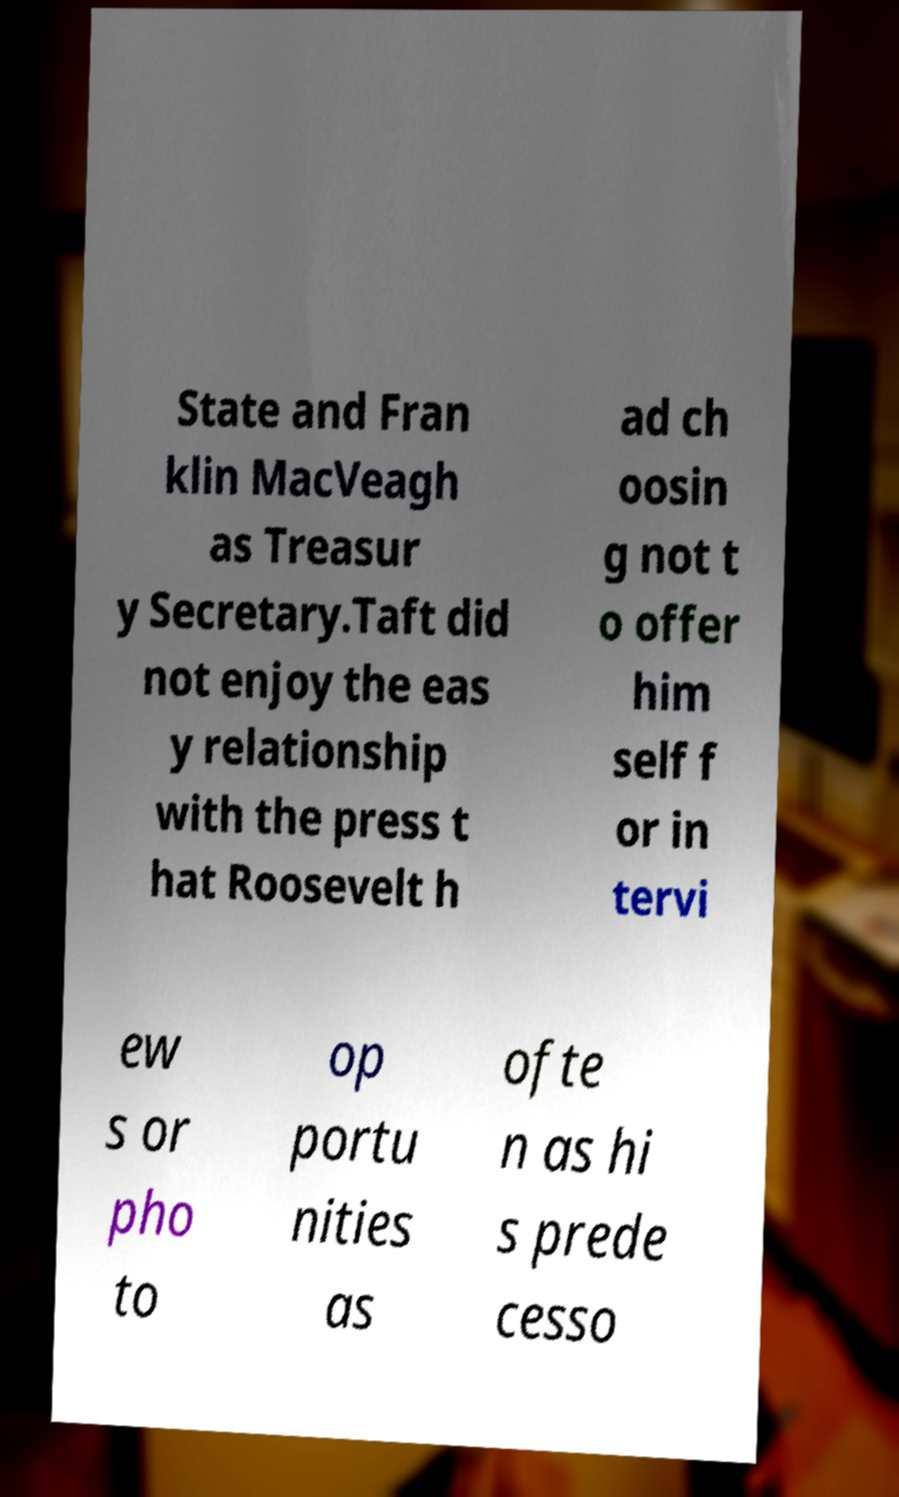What messages or text are displayed in this image? I need them in a readable, typed format. State and Fran klin MacVeagh as Treasur y Secretary.Taft did not enjoy the eas y relationship with the press t hat Roosevelt h ad ch oosin g not t o offer him self f or in tervi ew s or pho to op portu nities as ofte n as hi s prede cesso 